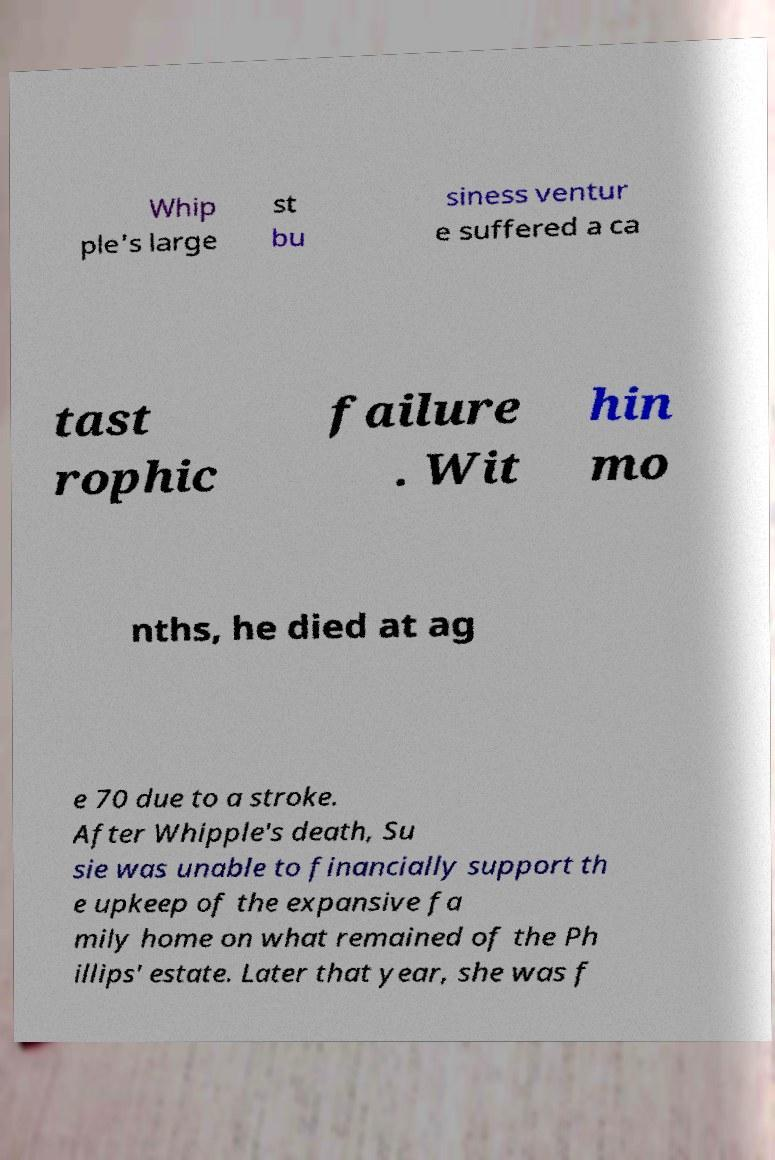I need the written content from this picture converted into text. Can you do that? Whip ple's large st bu siness ventur e suffered a ca tast rophic failure . Wit hin mo nths, he died at ag e 70 due to a stroke. After Whipple's death, Su sie was unable to financially support th e upkeep of the expansive fa mily home on what remained of the Ph illips' estate. Later that year, she was f 